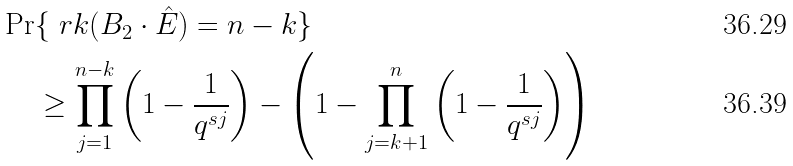<formula> <loc_0><loc_0><loc_500><loc_500>\Pr & \{ \ r k ( B _ { 2 } \cdot \hat { E } ) = n - k \} \\ & \geq \prod _ { j = 1 } ^ { n - k } \left ( 1 - \frac { 1 } { q ^ { s j } } \right ) - \left ( 1 - \prod _ { j = k + 1 } ^ { n } \left ( 1 - \frac { 1 } { q ^ { s j } } \right ) \right )</formula> 